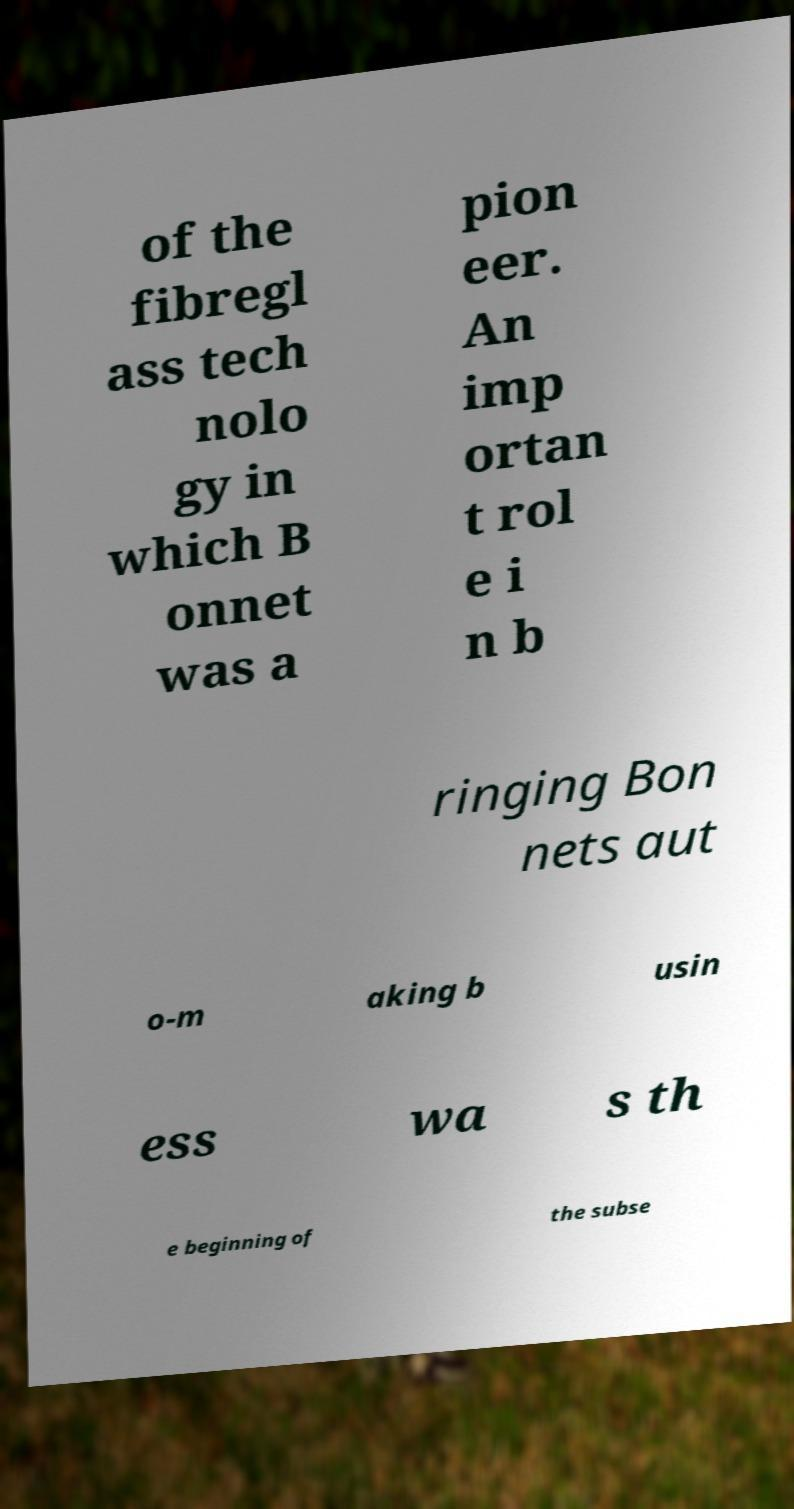Can you accurately transcribe the text from the provided image for me? of the fibregl ass tech nolo gy in which B onnet was a pion eer. An imp ortan t rol e i n b ringing Bon nets aut o-m aking b usin ess wa s th e beginning of the subse 